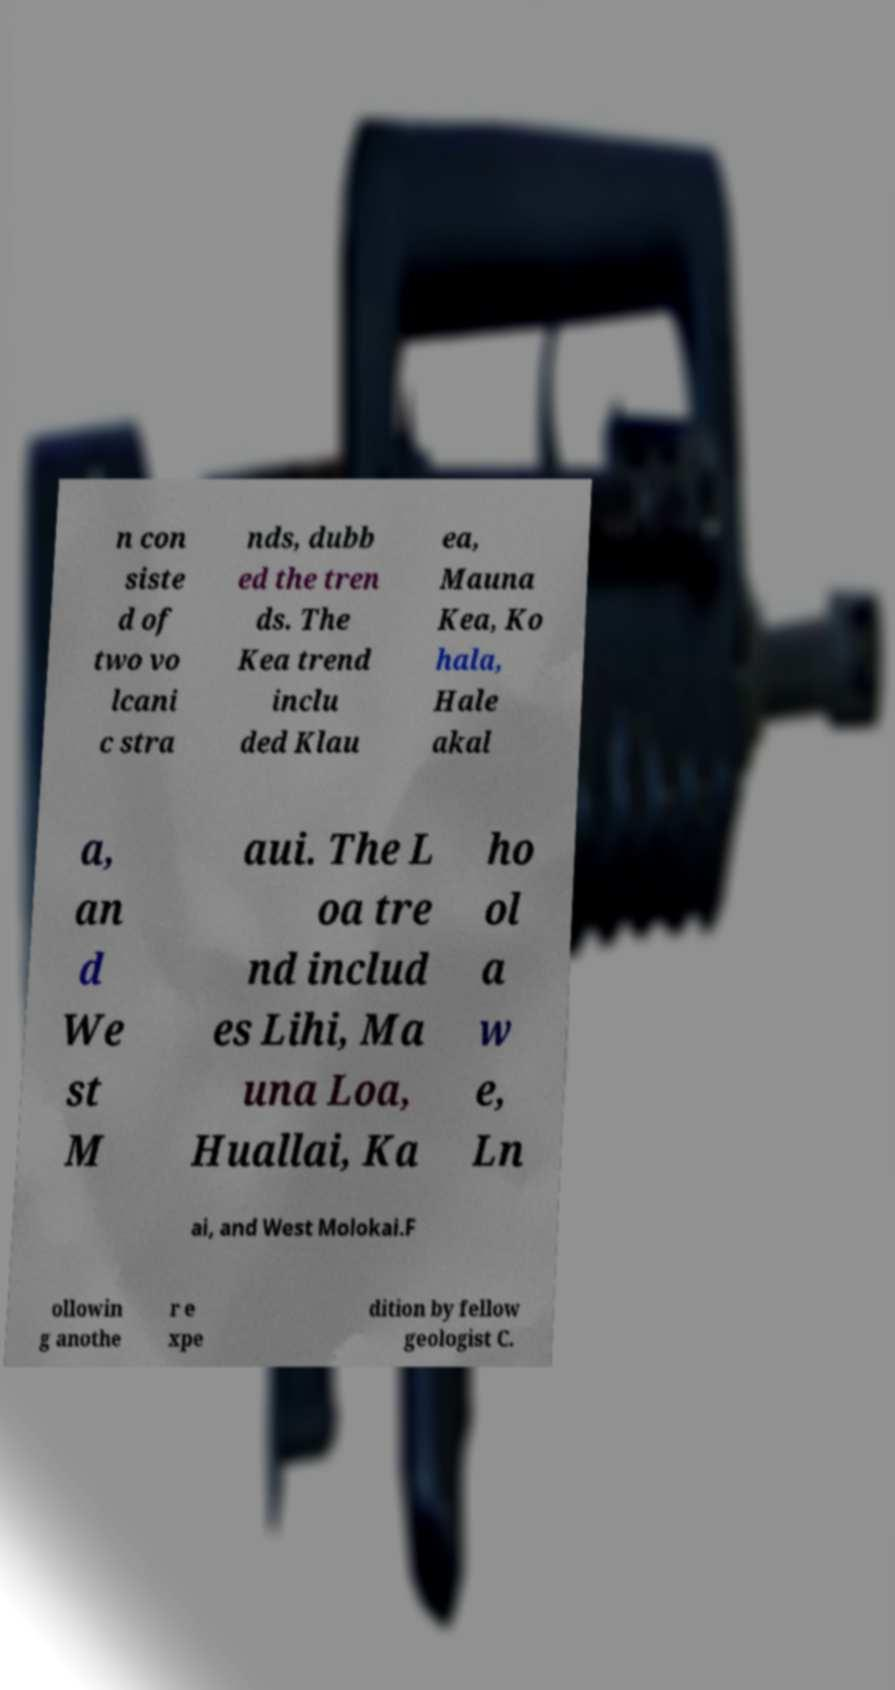Could you assist in decoding the text presented in this image and type it out clearly? n con siste d of two vo lcani c stra nds, dubb ed the tren ds. The Kea trend inclu ded Klau ea, Mauna Kea, Ko hala, Hale akal a, an d We st M aui. The L oa tre nd includ es Lihi, Ma una Loa, Huallai, Ka ho ol a w e, Ln ai, and West Molokai.F ollowin g anothe r e xpe dition by fellow geologist C. 